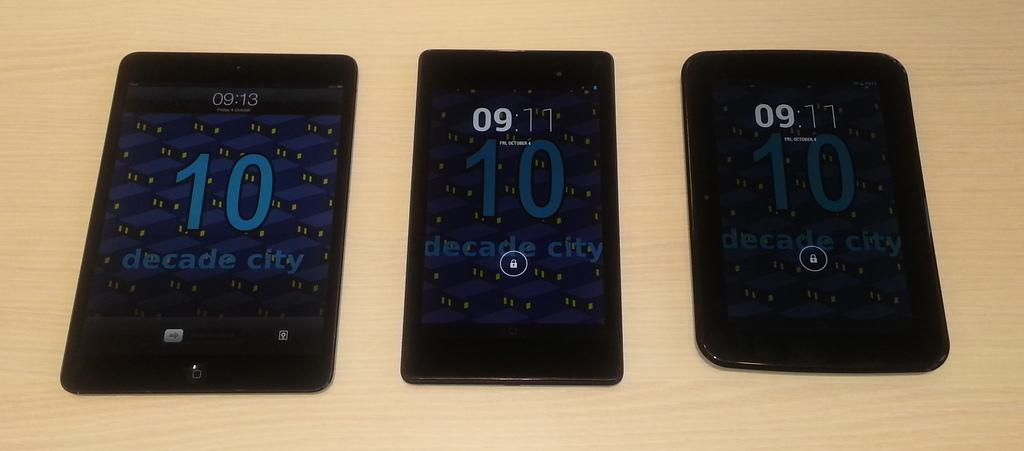<image>
Relay a brief, clear account of the picture shown. Three black cell phones laying in a row, one displaying the time as 09:13 with the others showing 09:11. 